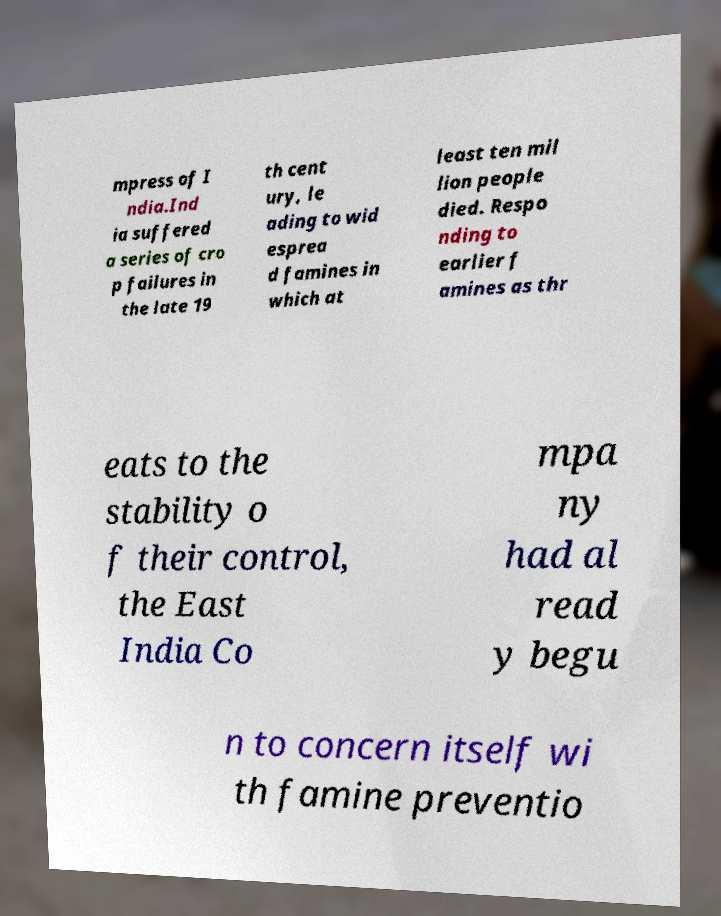Can you read and provide the text displayed in the image?This photo seems to have some interesting text. Can you extract and type it out for me? mpress of I ndia.Ind ia suffered a series of cro p failures in the late 19 th cent ury, le ading to wid esprea d famines in which at least ten mil lion people died. Respo nding to earlier f amines as thr eats to the stability o f their control, the East India Co mpa ny had al read y begu n to concern itself wi th famine preventio 